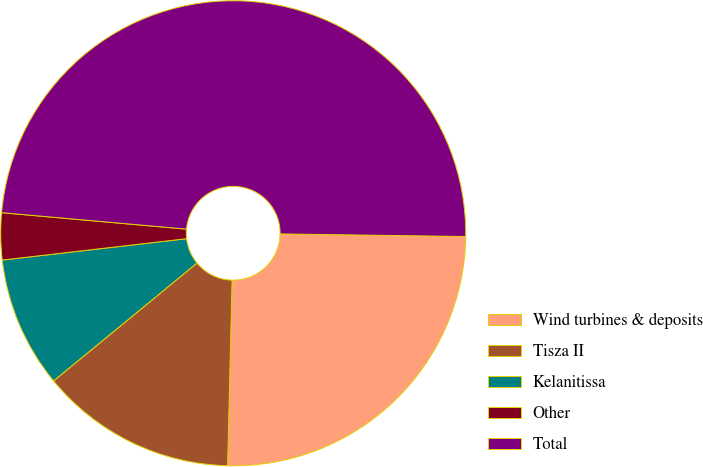Convert chart. <chart><loc_0><loc_0><loc_500><loc_500><pie_chart><fcel>Wind turbines & deposits<fcel>Tisza II<fcel>Kelanitissa<fcel>Other<fcel>Total<nl><fcel>25.16%<fcel>13.67%<fcel>9.11%<fcel>3.25%<fcel>48.81%<nl></chart> 